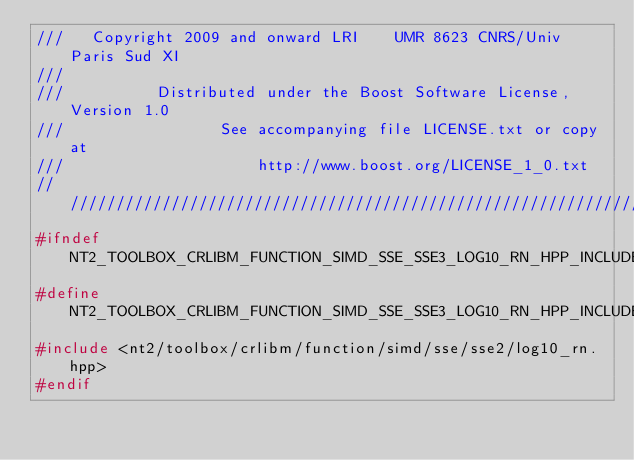<code> <loc_0><loc_0><loc_500><loc_500><_C++_>///   Copyright 2009 and onward LRI    UMR 8623 CNRS/Univ Paris Sud XI
///
///          Distributed under the Boost Software License, Version 1.0
///                 See accompanying file LICENSE.txt or copy at
///                     http://www.boost.org/LICENSE_1_0.txt
//////////////////////////////////////////////////////////////////////////////
#ifndef NT2_TOOLBOX_CRLIBM_FUNCTION_SIMD_SSE_SSE3_LOG10_RN_HPP_INCLUDED
#define NT2_TOOLBOX_CRLIBM_FUNCTION_SIMD_SSE_SSE3_LOG10_RN_HPP_INCLUDED
#include <nt2/toolbox/crlibm/function/simd/sse/sse2/log10_rn.hpp>
#endif
</code> 